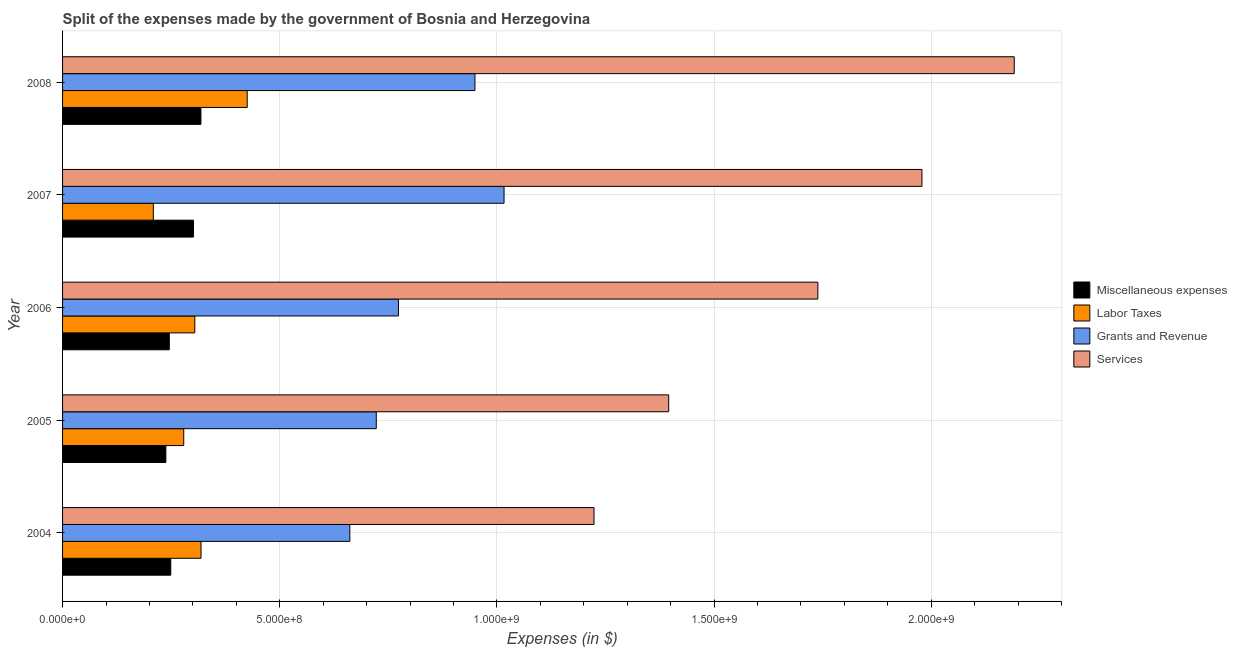How many groups of bars are there?
Make the answer very short. 5. How many bars are there on the 3rd tick from the bottom?
Ensure brevity in your answer.  4. What is the amount spent on services in 2005?
Offer a very short reply. 1.40e+09. Across all years, what is the maximum amount spent on miscellaneous expenses?
Give a very brief answer. 3.19e+08. Across all years, what is the minimum amount spent on miscellaneous expenses?
Your response must be concise. 2.38e+08. In which year was the amount spent on labor taxes minimum?
Give a very brief answer. 2007. What is the total amount spent on grants and revenue in the graph?
Your response must be concise. 4.12e+09. What is the difference between the amount spent on services in 2004 and that in 2007?
Your answer should be compact. -7.55e+08. What is the difference between the amount spent on grants and revenue in 2007 and the amount spent on services in 2008?
Offer a terse response. -1.17e+09. What is the average amount spent on labor taxes per year?
Provide a short and direct response. 3.07e+08. In the year 2007, what is the difference between the amount spent on labor taxes and amount spent on grants and revenue?
Offer a terse response. -8.07e+08. What is the ratio of the amount spent on labor taxes in 2005 to that in 2006?
Your answer should be compact. 0.92. Is the amount spent on grants and revenue in 2005 less than that in 2006?
Provide a succinct answer. Yes. Is the difference between the amount spent on services in 2005 and 2006 greater than the difference between the amount spent on grants and revenue in 2005 and 2006?
Your answer should be compact. No. What is the difference between the highest and the second highest amount spent on services?
Provide a short and direct response. 2.13e+08. What is the difference between the highest and the lowest amount spent on services?
Provide a short and direct response. 9.67e+08. Is the sum of the amount spent on labor taxes in 2007 and 2008 greater than the maximum amount spent on miscellaneous expenses across all years?
Give a very brief answer. Yes. What does the 4th bar from the top in 2006 represents?
Ensure brevity in your answer.  Miscellaneous expenses. What does the 1st bar from the bottom in 2007 represents?
Your response must be concise. Miscellaneous expenses. Is it the case that in every year, the sum of the amount spent on miscellaneous expenses and amount spent on labor taxes is greater than the amount spent on grants and revenue?
Your answer should be compact. No. Are all the bars in the graph horizontal?
Give a very brief answer. Yes. How many years are there in the graph?
Offer a very short reply. 5. What is the difference between two consecutive major ticks on the X-axis?
Your response must be concise. 5.00e+08. How many legend labels are there?
Your answer should be very brief. 4. How are the legend labels stacked?
Offer a very short reply. Vertical. What is the title of the graph?
Your answer should be compact. Split of the expenses made by the government of Bosnia and Herzegovina. What is the label or title of the X-axis?
Your response must be concise. Expenses (in $). What is the Expenses (in $) of Miscellaneous expenses in 2004?
Give a very brief answer. 2.49e+08. What is the Expenses (in $) in Labor Taxes in 2004?
Provide a short and direct response. 3.19e+08. What is the Expenses (in $) in Grants and Revenue in 2004?
Ensure brevity in your answer.  6.61e+08. What is the Expenses (in $) of Services in 2004?
Keep it short and to the point. 1.22e+09. What is the Expenses (in $) in Miscellaneous expenses in 2005?
Your answer should be very brief. 2.38e+08. What is the Expenses (in $) in Labor Taxes in 2005?
Your answer should be very brief. 2.79e+08. What is the Expenses (in $) in Grants and Revenue in 2005?
Provide a succinct answer. 7.22e+08. What is the Expenses (in $) in Services in 2005?
Offer a very short reply. 1.40e+09. What is the Expenses (in $) of Miscellaneous expenses in 2006?
Offer a terse response. 2.46e+08. What is the Expenses (in $) in Labor Taxes in 2006?
Your response must be concise. 3.04e+08. What is the Expenses (in $) in Grants and Revenue in 2006?
Offer a very short reply. 7.73e+08. What is the Expenses (in $) of Services in 2006?
Ensure brevity in your answer.  1.74e+09. What is the Expenses (in $) of Miscellaneous expenses in 2007?
Offer a very short reply. 3.01e+08. What is the Expenses (in $) of Labor Taxes in 2007?
Make the answer very short. 2.09e+08. What is the Expenses (in $) of Grants and Revenue in 2007?
Your answer should be compact. 1.02e+09. What is the Expenses (in $) in Services in 2007?
Offer a terse response. 1.98e+09. What is the Expenses (in $) of Miscellaneous expenses in 2008?
Ensure brevity in your answer.  3.19e+08. What is the Expenses (in $) of Labor Taxes in 2008?
Give a very brief answer. 4.25e+08. What is the Expenses (in $) in Grants and Revenue in 2008?
Your response must be concise. 9.49e+08. What is the Expenses (in $) in Services in 2008?
Make the answer very short. 2.19e+09. Across all years, what is the maximum Expenses (in $) in Miscellaneous expenses?
Provide a succinct answer. 3.19e+08. Across all years, what is the maximum Expenses (in $) of Labor Taxes?
Offer a terse response. 4.25e+08. Across all years, what is the maximum Expenses (in $) in Grants and Revenue?
Provide a short and direct response. 1.02e+09. Across all years, what is the maximum Expenses (in $) of Services?
Ensure brevity in your answer.  2.19e+09. Across all years, what is the minimum Expenses (in $) of Miscellaneous expenses?
Give a very brief answer. 2.38e+08. Across all years, what is the minimum Expenses (in $) in Labor Taxes?
Your answer should be very brief. 2.09e+08. Across all years, what is the minimum Expenses (in $) in Grants and Revenue?
Offer a very short reply. 6.61e+08. Across all years, what is the minimum Expenses (in $) in Services?
Make the answer very short. 1.22e+09. What is the total Expenses (in $) of Miscellaneous expenses in the graph?
Offer a very short reply. 1.35e+09. What is the total Expenses (in $) in Labor Taxes in the graph?
Provide a succinct answer. 1.54e+09. What is the total Expenses (in $) in Grants and Revenue in the graph?
Provide a succinct answer. 4.12e+09. What is the total Expenses (in $) in Services in the graph?
Give a very brief answer. 8.53e+09. What is the difference between the Expenses (in $) of Miscellaneous expenses in 2004 and that in 2005?
Offer a very short reply. 1.13e+07. What is the difference between the Expenses (in $) in Labor Taxes in 2004 and that in 2005?
Offer a terse response. 3.98e+07. What is the difference between the Expenses (in $) of Grants and Revenue in 2004 and that in 2005?
Ensure brevity in your answer.  -6.09e+07. What is the difference between the Expenses (in $) in Services in 2004 and that in 2005?
Your response must be concise. -1.72e+08. What is the difference between the Expenses (in $) of Miscellaneous expenses in 2004 and that in 2006?
Your answer should be very brief. 3.38e+06. What is the difference between the Expenses (in $) in Labor Taxes in 2004 and that in 2006?
Make the answer very short. 1.43e+07. What is the difference between the Expenses (in $) of Grants and Revenue in 2004 and that in 2006?
Keep it short and to the point. -1.12e+08. What is the difference between the Expenses (in $) in Services in 2004 and that in 2006?
Your response must be concise. -5.15e+08. What is the difference between the Expenses (in $) in Miscellaneous expenses in 2004 and that in 2007?
Ensure brevity in your answer.  -5.23e+07. What is the difference between the Expenses (in $) of Labor Taxes in 2004 and that in 2007?
Give a very brief answer. 1.10e+08. What is the difference between the Expenses (in $) in Grants and Revenue in 2004 and that in 2007?
Provide a succinct answer. -3.55e+08. What is the difference between the Expenses (in $) in Services in 2004 and that in 2007?
Make the answer very short. -7.55e+08. What is the difference between the Expenses (in $) in Miscellaneous expenses in 2004 and that in 2008?
Keep it short and to the point. -6.94e+07. What is the difference between the Expenses (in $) in Labor Taxes in 2004 and that in 2008?
Provide a short and direct response. -1.06e+08. What is the difference between the Expenses (in $) of Grants and Revenue in 2004 and that in 2008?
Keep it short and to the point. -2.88e+08. What is the difference between the Expenses (in $) in Services in 2004 and that in 2008?
Offer a terse response. -9.67e+08. What is the difference between the Expenses (in $) of Miscellaneous expenses in 2005 and that in 2006?
Provide a short and direct response. -7.90e+06. What is the difference between the Expenses (in $) in Labor Taxes in 2005 and that in 2006?
Your answer should be compact. -2.55e+07. What is the difference between the Expenses (in $) in Grants and Revenue in 2005 and that in 2006?
Make the answer very short. -5.11e+07. What is the difference between the Expenses (in $) in Services in 2005 and that in 2006?
Your answer should be very brief. -3.43e+08. What is the difference between the Expenses (in $) of Miscellaneous expenses in 2005 and that in 2007?
Ensure brevity in your answer.  -6.36e+07. What is the difference between the Expenses (in $) in Labor Taxes in 2005 and that in 2007?
Make the answer very short. 7.00e+07. What is the difference between the Expenses (in $) of Grants and Revenue in 2005 and that in 2007?
Your response must be concise. -2.94e+08. What is the difference between the Expenses (in $) in Services in 2005 and that in 2007?
Ensure brevity in your answer.  -5.83e+08. What is the difference between the Expenses (in $) of Miscellaneous expenses in 2005 and that in 2008?
Offer a terse response. -8.07e+07. What is the difference between the Expenses (in $) of Labor Taxes in 2005 and that in 2008?
Keep it short and to the point. -1.46e+08. What is the difference between the Expenses (in $) in Grants and Revenue in 2005 and that in 2008?
Provide a succinct answer. -2.27e+08. What is the difference between the Expenses (in $) of Services in 2005 and that in 2008?
Ensure brevity in your answer.  -7.96e+08. What is the difference between the Expenses (in $) in Miscellaneous expenses in 2006 and that in 2007?
Your response must be concise. -5.57e+07. What is the difference between the Expenses (in $) of Labor Taxes in 2006 and that in 2007?
Keep it short and to the point. 9.55e+07. What is the difference between the Expenses (in $) in Grants and Revenue in 2006 and that in 2007?
Your answer should be compact. -2.43e+08. What is the difference between the Expenses (in $) of Services in 2006 and that in 2007?
Ensure brevity in your answer.  -2.40e+08. What is the difference between the Expenses (in $) of Miscellaneous expenses in 2006 and that in 2008?
Your answer should be very brief. -7.28e+07. What is the difference between the Expenses (in $) in Labor Taxes in 2006 and that in 2008?
Ensure brevity in your answer.  -1.21e+08. What is the difference between the Expenses (in $) of Grants and Revenue in 2006 and that in 2008?
Your answer should be very brief. -1.76e+08. What is the difference between the Expenses (in $) of Services in 2006 and that in 2008?
Give a very brief answer. -4.52e+08. What is the difference between the Expenses (in $) of Miscellaneous expenses in 2007 and that in 2008?
Provide a short and direct response. -1.71e+07. What is the difference between the Expenses (in $) in Labor Taxes in 2007 and that in 2008?
Your answer should be compact. -2.16e+08. What is the difference between the Expenses (in $) of Grants and Revenue in 2007 and that in 2008?
Offer a very short reply. 6.70e+07. What is the difference between the Expenses (in $) of Services in 2007 and that in 2008?
Keep it short and to the point. -2.13e+08. What is the difference between the Expenses (in $) of Miscellaneous expenses in 2004 and the Expenses (in $) of Labor Taxes in 2005?
Your answer should be very brief. -2.99e+07. What is the difference between the Expenses (in $) of Miscellaneous expenses in 2004 and the Expenses (in $) of Grants and Revenue in 2005?
Give a very brief answer. -4.73e+08. What is the difference between the Expenses (in $) in Miscellaneous expenses in 2004 and the Expenses (in $) in Services in 2005?
Your answer should be very brief. -1.15e+09. What is the difference between the Expenses (in $) in Labor Taxes in 2004 and the Expenses (in $) in Grants and Revenue in 2005?
Give a very brief answer. -4.04e+08. What is the difference between the Expenses (in $) in Labor Taxes in 2004 and the Expenses (in $) in Services in 2005?
Your answer should be very brief. -1.08e+09. What is the difference between the Expenses (in $) of Grants and Revenue in 2004 and the Expenses (in $) of Services in 2005?
Provide a succinct answer. -7.34e+08. What is the difference between the Expenses (in $) in Miscellaneous expenses in 2004 and the Expenses (in $) in Labor Taxes in 2006?
Provide a succinct answer. -5.54e+07. What is the difference between the Expenses (in $) of Miscellaneous expenses in 2004 and the Expenses (in $) of Grants and Revenue in 2006?
Your response must be concise. -5.24e+08. What is the difference between the Expenses (in $) of Miscellaneous expenses in 2004 and the Expenses (in $) of Services in 2006?
Your answer should be compact. -1.49e+09. What is the difference between the Expenses (in $) of Labor Taxes in 2004 and the Expenses (in $) of Grants and Revenue in 2006?
Keep it short and to the point. -4.55e+08. What is the difference between the Expenses (in $) in Labor Taxes in 2004 and the Expenses (in $) in Services in 2006?
Provide a succinct answer. -1.42e+09. What is the difference between the Expenses (in $) of Grants and Revenue in 2004 and the Expenses (in $) of Services in 2006?
Your answer should be very brief. -1.08e+09. What is the difference between the Expenses (in $) of Miscellaneous expenses in 2004 and the Expenses (in $) of Labor Taxes in 2007?
Offer a very short reply. 4.02e+07. What is the difference between the Expenses (in $) in Miscellaneous expenses in 2004 and the Expenses (in $) in Grants and Revenue in 2007?
Your answer should be very brief. -7.67e+08. What is the difference between the Expenses (in $) of Miscellaneous expenses in 2004 and the Expenses (in $) of Services in 2007?
Provide a short and direct response. -1.73e+09. What is the difference between the Expenses (in $) of Labor Taxes in 2004 and the Expenses (in $) of Grants and Revenue in 2007?
Provide a succinct answer. -6.98e+08. What is the difference between the Expenses (in $) in Labor Taxes in 2004 and the Expenses (in $) in Services in 2007?
Offer a very short reply. -1.66e+09. What is the difference between the Expenses (in $) of Grants and Revenue in 2004 and the Expenses (in $) of Services in 2007?
Provide a short and direct response. -1.32e+09. What is the difference between the Expenses (in $) in Miscellaneous expenses in 2004 and the Expenses (in $) in Labor Taxes in 2008?
Your answer should be very brief. -1.76e+08. What is the difference between the Expenses (in $) in Miscellaneous expenses in 2004 and the Expenses (in $) in Grants and Revenue in 2008?
Offer a terse response. -7.00e+08. What is the difference between the Expenses (in $) of Miscellaneous expenses in 2004 and the Expenses (in $) of Services in 2008?
Make the answer very short. -1.94e+09. What is the difference between the Expenses (in $) in Labor Taxes in 2004 and the Expenses (in $) in Grants and Revenue in 2008?
Keep it short and to the point. -6.31e+08. What is the difference between the Expenses (in $) of Labor Taxes in 2004 and the Expenses (in $) of Services in 2008?
Ensure brevity in your answer.  -1.87e+09. What is the difference between the Expenses (in $) in Grants and Revenue in 2004 and the Expenses (in $) in Services in 2008?
Your answer should be compact. -1.53e+09. What is the difference between the Expenses (in $) in Miscellaneous expenses in 2005 and the Expenses (in $) in Labor Taxes in 2006?
Offer a very short reply. -6.66e+07. What is the difference between the Expenses (in $) of Miscellaneous expenses in 2005 and the Expenses (in $) of Grants and Revenue in 2006?
Offer a terse response. -5.36e+08. What is the difference between the Expenses (in $) of Miscellaneous expenses in 2005 and the Expenses (in $) of Services in 2006?
Offer a very short reply. -1.50e+09. What is the difference between the Expenses (in $) of Labor Taxes in 2005 and the Expenses (in $) of Grants and Revenue in 2006?
Your answer should be very brief. -4.94e+08. What is the difference between the Expenses (in $) of Labor Taxes in 2005 and the Expenses (in $) of Services in 2006?
Your response must be concise. -1.46e+09. What is the difference between the Expenses (in $) in Grants and Revenue in 2005 and the Expenses (in $) in Services in 2006?
Ensure brevity in your answer.  -1.02e+09. What is the difference between the Expenses (in $) in Miscellaneous expenses in 2005 and the Expenses (in $) in Labor Taxes in 2007?
Offer a terse response. 2.89e+07. What is the difference between the Expenses (in $) in Miscellaneous expenses in 2005 and the Expenses (in $) in Grants and Revenue in 2007?
Provide a succinct answer. -7.79e+08. What is the difference between the Expenses (in $) in Miscellaneous expenses in 2005 and the Expenses (in $) in Services in 2007?
Provide a short and direct response. -1.74e+09. What is the difference between the Expenses (in $) of Labor Taxes in 2005 and the Expenses (in $) of Grants and Revenue in 2007?
Your answer should be very brief. -7.37e+08. What is the difference between the Expenses (in $) in Labor Taxes in 2005 and the Expenses (in $) in Services in 2007?
Ensure brevity in your answer.  -1.70e+09. What is the difference between the Expenses (in $) of Grants and Revenue in 2005 and the Expenses (in $) of Services in 2007?
Offer a terse response. -1.26e+09. What is the difference between the Expenses (in $) of Miscellaneous expenses in 2005 and the Expenses (in $) of Labor Taxes in 2008?
Your answer should be compact. -1.87e+08. What is the difference between the Expenses (in $) of Miscellaneous expenses in 2005 and the Expenses (in $) of Grants and Revenue in 2008?
Provide a succinct answer. -7.12e+08. What is the difference between the Expenses (in $) in Miscellaneous expenses in 2005 and the Expenses (in $) in Services in 2008?
Your answer should be very brief. -1.95e+09. What is the difference between the Expenses (in $) of Labor Taxes in 2005 and the Expenses (in $) of Grants and Revenue in 2008?
Your answer should be compact. -6.70e+08. What is the difference between the Expenses (in $) in Labor Taxes in 2005 and the Expenses (in $) in Services in 2008?
Make the answer very short. -1.91e+09. What is the difference between the Expenses (in $) in Grants and Revenue in 2005 and the Expenses (in $) in Services in 2008?
Offer a terse response. -1.47e+09. What is the difference between the Expenses (in $) in Miscellaneous expenses in 2006 and the Expenses (in $) in Labor Taxes in 2007?
Offer a terse response. 3.68e+07. What is the difference between the Expenses (in $) of Miscellaneous expenses in 2006 and the Expenses (in $) of Grants and Revenue in 2007?
Your answer should be compact. -7.71e+08. What is the difference between the Expenses (in $) in Miscellaneous expenses in 2006 and the Expenses (in $) in Services in 2007?
Give a very brief answer. -1.73e+09. What is the difference between the Expenses (in $) in Labor Taxes in 2006 and the Expenses (in $) in Grants and Revenue in 2007?
Make the answer very short. -7.12e+08. What is the difference between the Expenses (in $) in Labor Taxes in 2006 and the Expenses (in $) in Services in 2007?
Offer a terse response. -1.67e+09. What is the difference between the Expenses (in $) in Grants and Revenue in 2006 and the Expenses (in $) in Services in 2007?
Make the answer very short. -1.21e+09. What is the difference between the Expenses (in $) in Miscellaneous expenses in 2006 and the Expenses (in $) in Labor Taxes in 2008?
Give a very brief answer. -1.79e+08. What is the difference between the Expenses (in $) in Miscellaneous expenses in 2006 and the Expenses (in $) in Grants and Revenue in 2008?
Give a very brief answer. -7.04e+08. What is the difference between the Expenses (in $) of Miscellaneous expenses in 2006 and the Expenses (in $) of Services in 2008?
Offer a terse response. -1.95e+09. What is the difference between the Expenses (in $) in Labor Taxes in 2006 and the Expenses (in $) in Grants and Revenue in 2008?
Your answer should be compact. -6.45e+08. What is the difference between the Expenses (in $) of Labor Taxes in 2006 and the Expenses (in $) of Services in 2008?
Your response must be concise. -1.89e+09. What is the difference between the Expenses (in $) of Grants and Revenue in 2006 and the Expenses (in $) of Services in 2008?
Provide a succinct answer. -1.42e+09. What is the difference between the Expenses (in $) in Miscellaneous expenses in 2007 and the Expenses (in $) in Labor Taxes in 2008?
Provide a succinct answer. -1.24e+08. What is the difference between the Expenses (in $) of Miscellaneous expenses in 2007 and the Expenses (in $) of Grants and Revenue in 2008?
Offer a very short reply. -6.48e+08. What is the difference between the Expenses (in $) of Miscellaneous expenses in 2007 and the Expenses (in $) of Services in 2008?
Offer a very short reply. -1.89e+09. What is the difference between the Expenses (in $) in Labor Taxes in 2007 and the Expenses (in $) in Grants and Revenue in 2008?
Ensure brevity in your answer.  -7.40e+08. What is the difference between the Expenses (in $) in Labor Taxes in 2007 and the Expenses (in $) in Services in 2008?
Your answer should be compact. -1.98e+09. What is the difference between the Expenses (in $) of Grants and Revenue in 2007 and the Expenses (in $) of Services in 2008?
Make the answer very short. -1.17e+09. What is the average Expenses (in $) in Miscellaneous expenses per year?
Your answer should be very brief. 2.71e+08. What is the average Expenses (in $) in Labor Taxes per year?
Offer a terse response. 3.07e+08. What is the average Expenses (in $) of Grants and Revenue per year?
Your answer should be very brief. 8.25e+08. What is the average Expenses (in $) in Services per year?
Offer a very short reply. 1.71e+09. In the year 2004, what is the difference between the Expenses (in $) in Miscellaneous expenses and Expenses (in $) in Labor Taxes?
Provide a succinct answer. -6.97e+07. In the year 2004, what is the difference between the Expenses (in $) of Miscellaneous expenses and Expenses (in $) of Grants and Revenue?
Offer a terse response. -4.12e+08. In the year 2004, what is the difference between the Expenses (in $) in Miscellaneous expenses and Expenses (in $) in Services?
Make the answer very short. -9.74e+08. In the year 2004, what is the difference between the Expenses (in $) in Labor Taxes and Expenses (in $) in Grants and Revenue?
Provide a short and direct response. -3.43e+08. In the year 2004, what is the difference between the Expenses (in $) in Labor Taxes and Expenses (in $) in Services?
Your response must be concise. -9.05e+08. In the year 2004, what is the difference between the Expenses (in $) of Grants and Revenue and Expenses (in $) of Services?
Keep it short and to the point. -5.62e+08. In the year 2005, what is the difference between the Expenses (in $) in Miscellaneous expenses and Expenses (in $) in Labor Taxes?
Provide a short and direct response. -4.12e+07. In the year 2005, what is the difference between the Expenses (in $) of Miscellaneous expenses and Expenses (in $) of Grants and Revenue?
Provide a succinct answer. -4.84e+08. In the year 2005, what is the difference between the Expenses (in $) in Miscellaneous expenses and Expenses (in $) in Services?
Your answer should be compact. -1.16e+09. In the year 2005, what is the difference between the Expenses (in $) in Labor Taxes and Expenses (in $) in Grants and Revenue?
Your answer should be very brief. -4.43e+08. In the year 2005, what is the difference between the Expenses (in $) in Labor Taxes and Expenses (in $) in Services?
Give a very brief answer. -1.12e+09. In the year 2005, what is the difference between the Expenses (in $) of Grants and Revenue and Expenses (in $) of Services?
Provide a succinct answer. -6.73e+08. In the year 2006, what is the difference between the Expenses (in $) in Miscellaneous expenses and Expenses (in $) in Labor Taxes?
Your answer should be very brief. -5.87e+07. In the year 2006, what is the difference between the Expenses (in $) of Miscellaneous expenses and Expenses (in $) of Grants and Revenue?
Your answer should be very brief. -5.28e+08. In the year 2006, what is the difference between the Expenses (in $) of Miscellaneous expenses and Expenses (in $) of Services?
Offer a terse response. -1.49e+09. In the year 2006, what is the difference between the Expenses (in $) in Labor Taxes and Expenses (in $) in Grants and Revenue?
Provide a short and direct response. -4.69e+08. In the year 2006, what is the difference between the Expenses (in $) of Labor Taxes and Expenses (in $) of Services?
Offer a terse response. -1.43e+09. In the year 2006, what is the difference between the Expenses (in $) in Grants and Revenue and Expenses (in $) in Services?
Your response must be concise. -9.66e+08. In the year 2007, what is the difference between the Expenses (in $) in Miscellaneous expenses and Expenses (in $) in Labor Taxes?
Your answer should be very brief. 9.25e+07. In the year 2007, what is the difference between the Expenses (in $) in Miscellaneous expenses and Expenses (in $) in Grants and Revenue?
Offer a very short reply. -7.15e+08. In the year 2007, what is the difference between the Expenses (in $) in Miscellaneous expenses and Expenses (in $) in Services?
Keep it short and to the point. -1.68e+09. In the year 2007, what is the difference between the Expenses (in $) in Labor Taxes and Expenses (in $) in Grants and Revenue?
Keep it short and to the point. -8.07e+08. In the year 2007, what is the difference between the Expenses (in $) of Labor Taxes and Expenses (in $) of Services?
Give a very brief answer. -1.77e+09. In the year 2007, what is the difference between the Expenses (in $) of Grants and Revenue and Expenses (in $) of Services?
Provide a short and direct response. -9.62e+08. In the year 2008, what is the difference between the Expenses (in $) of Miscellaneous expenses and Expenses (in $) of Labor Taxes?
Your answer should be very brief. -1.07e+08. In the year 2008, what is the difference between the Expenses (in $) of Miscellaneous expenses and Expenses (in $) of Grants and Revenue?
Offer a terse response. -6.31e+08. In the year 2008, what is the difference between the Expenses (in $) of Miscellaneous expenses and Expenses (in $) of Services?
Your answer should be very brief. -1.87e+09. In the year 2008, what is the difference between the Expenses (in $) in Labor Taxes and Expenses (in $) in Grants and Revenue?
Your answer should be very brief. -5.24e+08. In the year 2008, what is the difference between the Expenses (in $) of Labor Taxes and Expenses (in $) of Services?
Offer a terse response. -1.77e+09. In the year 2008, what is the difference between the Expenses (in $) in Grants and Revenue and Expenses (in $) in Services?
Give a very brief answer. -1.24e+09. What is the ratio of the Expenses (in $) of Miscellaneous expenses in 2004 to that in 2005?
Offer a terse response. 1.05. What is the ratio of the Expenses (in $) in Labor Taxes in 2004 to that in 2005?
Offer a very short reply. 1.14. What is the ratio of the Expenses (in $) in Grants and Revenue in 2004 to that in 2005?
Give a very brief answer. 0.92. What is the ratio of the Expenses (in $) in Services in 2004 to that in 2005?
Give a very brief answer. 0.88. What is the ratio of the Expenses (in $) of Miscellaneous expenses in 2004 to that in 2006?
Provide a short and direct response. 1.01. What is the ratio of the Expenses (in $) in Labor Taxes in 2004 to that in 2006?
Your response must be concise. 1.05. What is the ratio of the Expenses (in $) in Grants and Revenue in 2004 to that in 2006?
Provide a short and direct response. 0.86. What is the ratio of the Expenses (in $) in Services in 2004 to that in 2006?
Your response must be concise. 0.7. What is the ratio of the Expenses (in $) of Miscellaneous expenses in 2004 to that in 2007?
Make the answer very short. 0.83. What is the ratio of the Expenses (in $) of Labor Taxes in 2004 to that in 2007?
Offer a very short reply. 1.53. What is the ratio of the Expenses (in $) of Grants and Revenue in 2004 to that in 2007?
Your answer should be very brief. 0.65. What is the ratio of the Expenses (in $) of Services in 2004 to that in 2007?
Offer a very short reply. 0.62. What is the ratio of the Expenses (in $) in Miscellaneous expenses in 2004 to that in 2008?
Give a very brief answer. 0.78. What is the ratio of the Expenses (in $) of Labor Taxes in 2004 to that in 2008?
Offer a terse response. 0.75. What is the ratio of the Expenses (in $) of Grants and Revenue in 2004 to that in 2008?
Your answer should be compact. 0.7. What is the ratio of the Expenses (in $) of Services in 2004 to that in 2008?
Offer a terse response. 0.56. What is the ratio of the Expenses (in $) in Miscellaneous expenses in 2005 to that in 2006?
Your response must be concise. 0.97. What is the ratio of the Expenses (in $) of Labor Taxes in 2005 to that in 2006?
Make the answer very short. 0.92. What is the ratio of the Expenses (in $) of Grants and Revenue in 2005 to that in 2006?
Your response must be concise. 0.93. What is the ratio of the Expenses (in $) of Services in 2005 to that in 2006?
Provide a short and direct response. 0.8. What is the ratio of the Expenses (in $) of Miscellaneous expenses in 2005 to that in 2007?
Keep it short and to the point. 0.79. What is the ratio of the Expenses (in $) in Labor Taxes in 2005 to that in 2007?
Your answer should be compact. 1.34. What is the ratio of the Expenses (in $) of Grants and Revenue in 2005 to that in 2007?
Your answer should be very brief. 0.71. What is the ratio of the Expenses (in $) in Services in 2005 to that in 2007?
Your response must be concise. 0.71. What is the ratio of the Expenses (in $) in Miscellaneous expenses in 2005 to that in 2008?
Ensure brevity in your answer.  0.75. What is the ratio of the Expenses (in $) of Labor Taxes in 2005 to that in 2008?
Provide a succinct answer. 0.66. What is the ratio of the Expenses (in $) of Grants and Revenue in 2005 to that in 2008?
Your answer should be very brief. 0.76. What is the ratio of the Expenses (in $) in Services in 2005 to that in 2008?
Your response must be concise. 0.64. What is the ratio of the Expenses (in $) in Miscellaneous expenses in 2006 to that in 2007?
Ensure brevity in your answer.  0.82. What is the ratio of the Expenses (in $) of Labor Taxes in 2006 to that in 2007?
Offer a terse response. 1.46. What is the ratio of the Expenses (in $) of Grants and Revenue in 2006 to that in 2007?
Provide a short and direct response. 0.76. What is the ratio of the Expenses (in $) in Services in 2006 to that in 2007?
Ensure brevity in your answer.  0.88. What is the ratio of the Expenses (in $) of Miscellaneous expenses in 2006 to that in 2008?
Keep it short and to the point. 0.77. What is the ratio of the Expenses (in $) in Labor Taxes in 2006 to that in 2008?
Your answer should be compact. 0.72. What is the ratio of the Expenses (in $) of Grants and Revenue in 2006 to that in 2008?
Keep it short and to the point. 0.81. What is the ratio of the Expenses (in $) of Services in 2006 to that in 2008?
Your response must be concise. 0.79. What is the ratio of the Expenses (in $) of Miscellaneous expenses in 2007 to that in 2008?
Provide a short and direct response. 0.95. What is the ratio of the Expenses (in $) of Labor Taxes in 2007 to that in 2008?
Provide a succinct answer. 0.49. What is the ratio of the Expenses (in $) in Grants and Revenue in 2007 to that in 2008?
Offer a terse response. 1.07. What is the ratio of the Expenses (in $) of Services in 2007 to that in 2008?
Your response must be concise. 0.9. What is the difference between the highest and the second highest Expenses (in $) in Miscellaneous expenses?
Your answer should be compact. 1.71e+07. What is the difference between the highest and the second highest Expenses (in $) of Labor Taxes?
Your answer should be very brief. 1.06e+08. What is the difference between the highest and the second highest Expenses (in $) of Grants and Revenue?
Your answer should be compact. 6.70e+07. What is the difference between the highest and the second highest Expenses (in $) of Services?
Provide a succinct answer. 2.13e+08. What is the difference between the highest and the lowest Expenses (in $) in Miscellaneous expenses?
Provide a short and direct response. 8.07e+07. What is the difference between the highest and the lowest Expenses (in $) of Labor Taxes?
Provide a succinct answer. 2.16e+08. What is the difference between the highest and the lowest Expenses (in $) in Grants and Revenue?
Give a very brief answer. 3.55e+08. What is the difference between the highest and the lowest Expenses (in $) in Services?
Offer a terse response. 9.67e+08. 